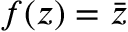<formula> <loc_0><loc_0><loc_500><loc_500>f ( z ) = { \bar { z } }</formula> 